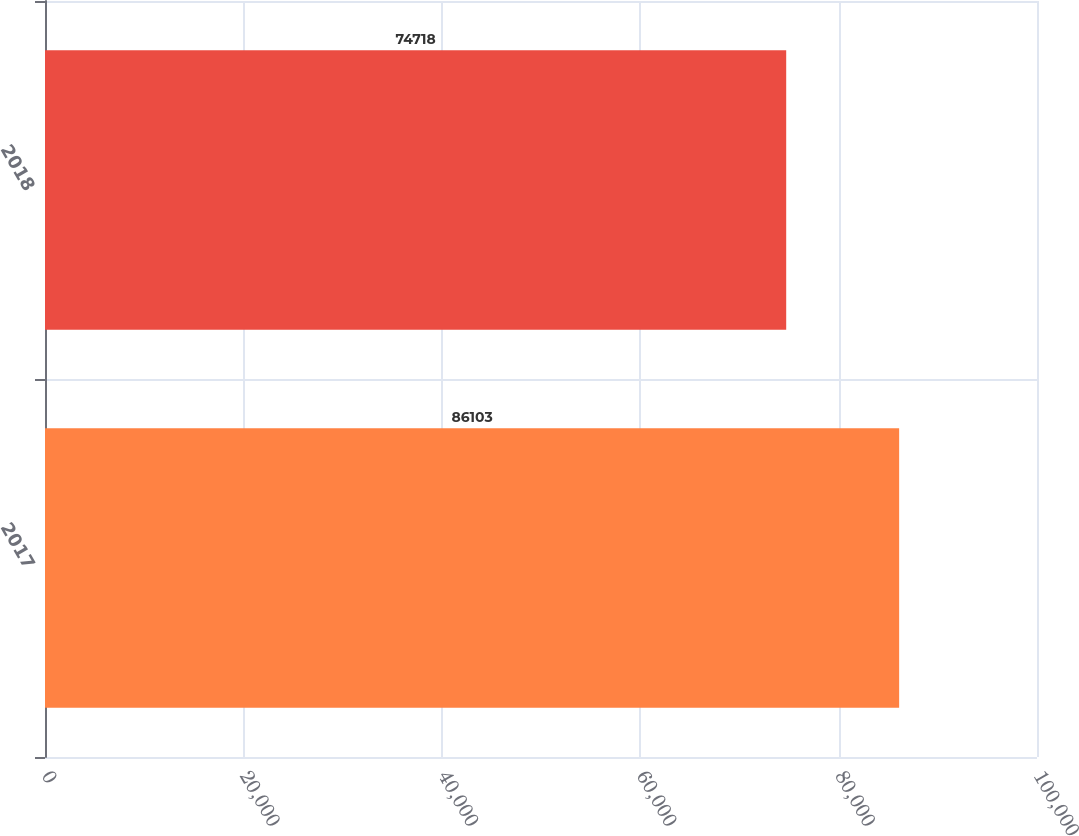Convert chart. <chart><loc_0><loc_0><loc_500><loc_500><bar_chart><fcel>2017<fcel>2018<nl><fcel>86103<fcel>74718<nl></chart> 